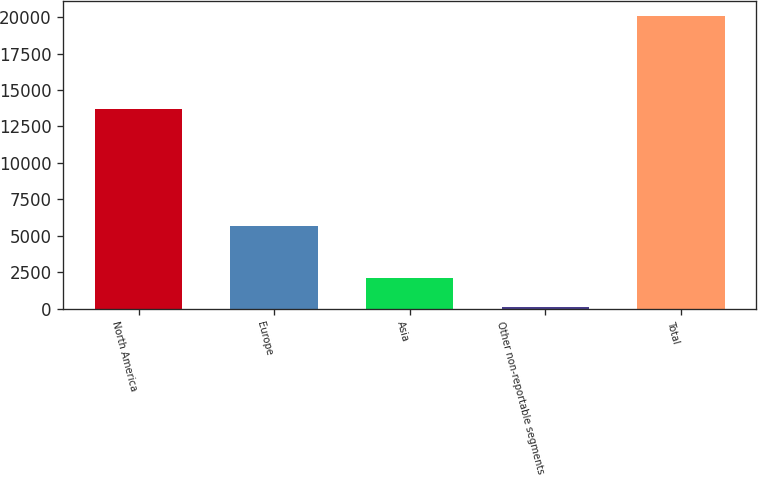Convert chart. <chart><loc_0><loc_0><loc_500><loc_500><bar_chart><fcel>North America<fcel>Europe<fcel>Asia<fcel>Other non-reportable segments<fcel>Total<nl><fcel>13680<fcel>5646<fcel>2123.7<fcel>128<fcel>20085<nl></chart> 